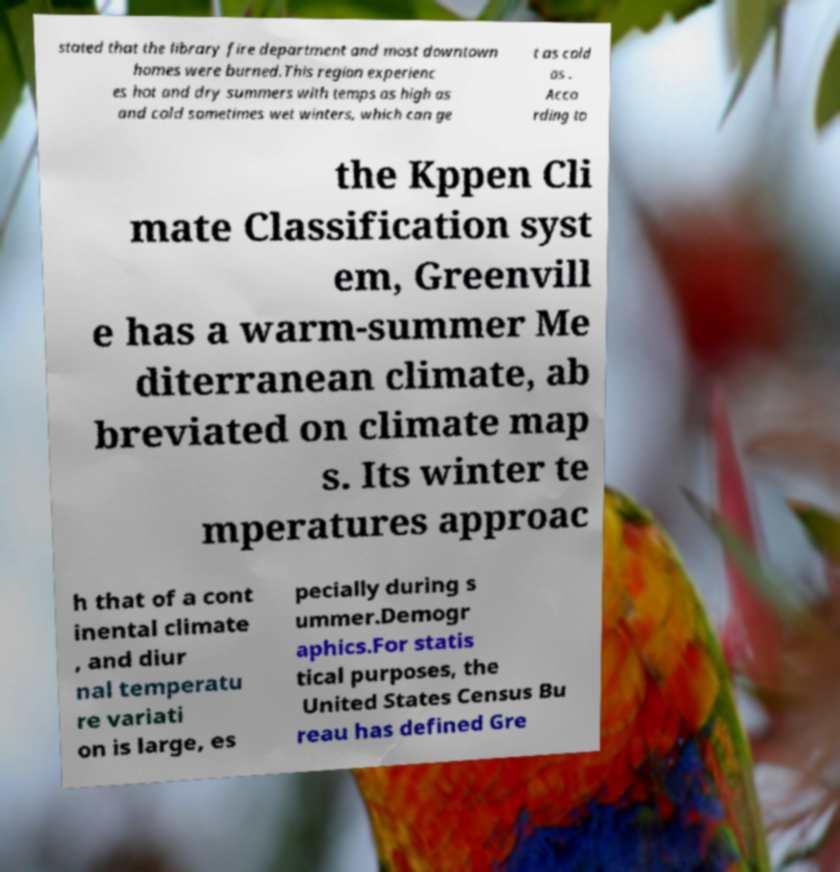Can you accurately transcribe the text from the provided image for me? stated that the library fire department and most downtown homes were burned.This region experienc es hot and dry summers with temps as high as and cold sometimes wet winters, which can ge t as cold as . Acco rding to the Kppen Cli mate Classification syst em, Greenvill e has a warm-summer Me diterranean climate, ab breviated on climate map s. Its winter te mperatures approac h that of a cont inental climate , and diur nal temperatu re variati on is large, es pecially during s ummer.Demogr aphics.For statis tical purposes, the United States Census Bu reau has defined Gre 